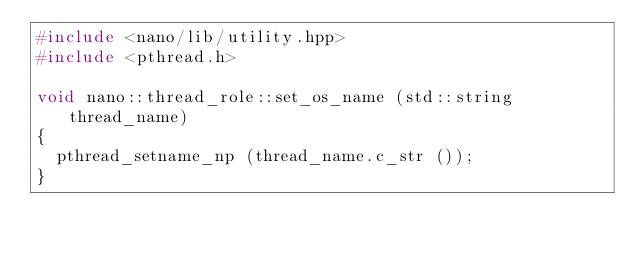<code> <loc_0><loc_0><loc_500><loc_500><_C++_>#include <nano/lib/utility.hpp>
#include <pthread.h>

void nano::thread_role::set_os_name (std::string thread_name)
{
	pthread_setname_np (thread_name.c_str ());
}
</code> 